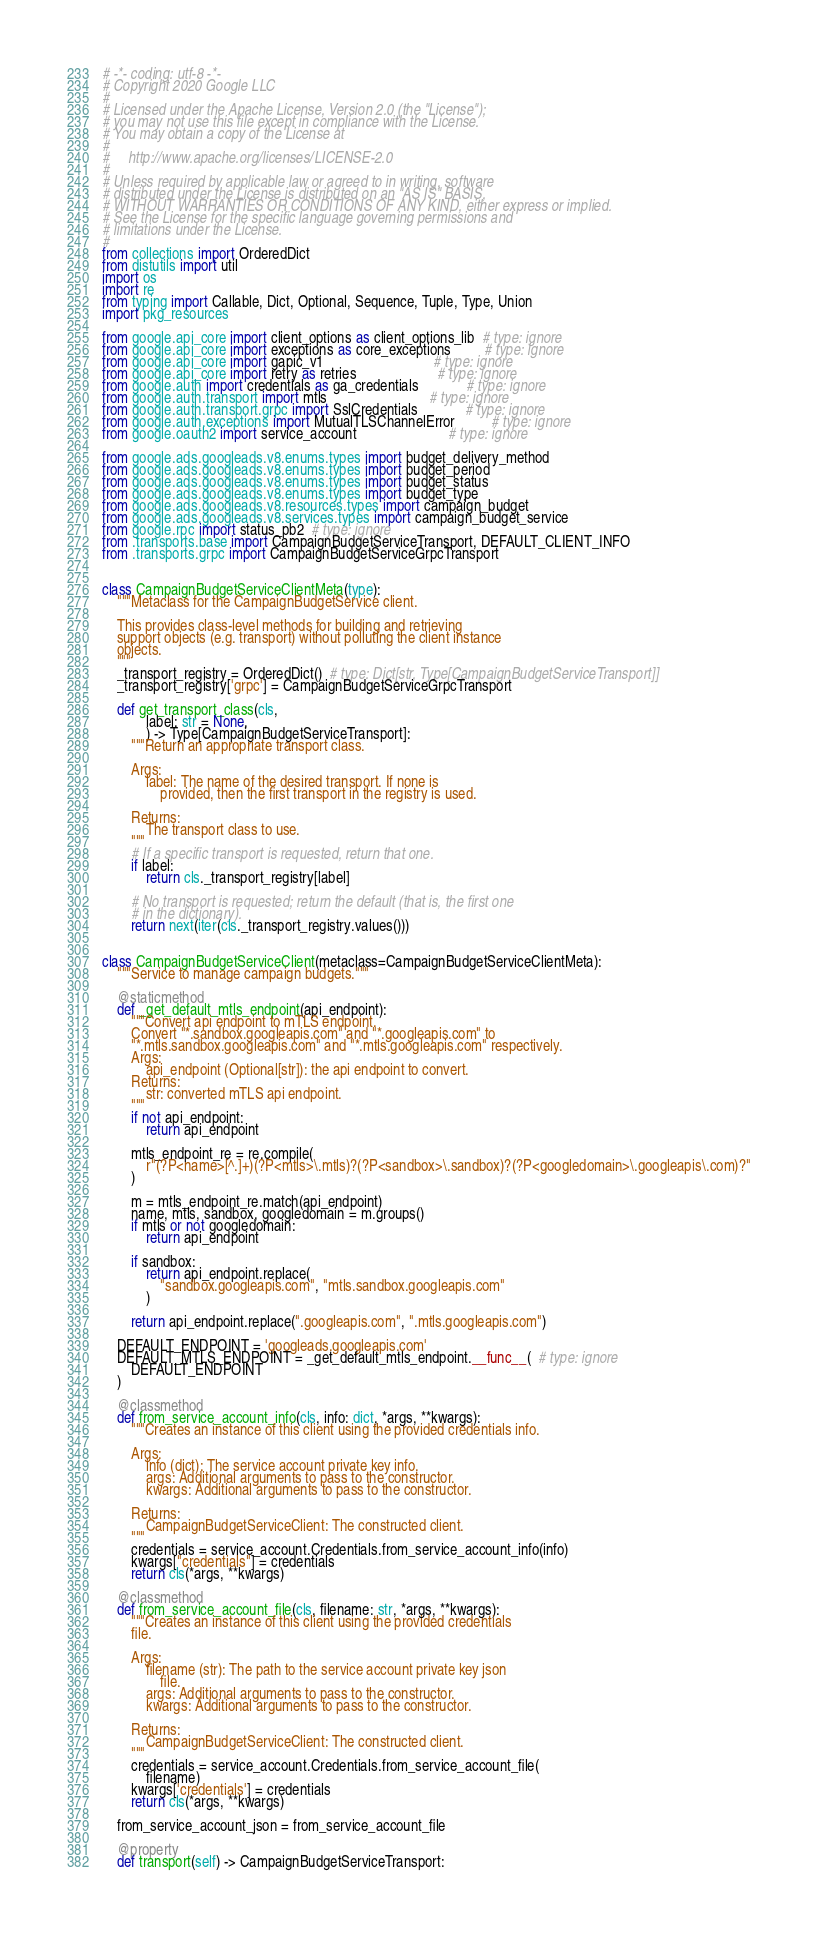Convert code to text. <code><loc_0><loc_0><loc_500><loc_500><_Python_># -*- coding: utf-8 -*-
# Copyright 2020 Google LLC
#
# Licensed under the Apache License, Version 2.0 (the "License");
# you may not use this file except in compliance with the License.
# You may obtain a copy of the License at
#
#     http://www.apache.org/licenses/LICENSE-2.0
#
# Unless required by applicable law or agreed to in writing, software
# distributed under the License is distributed on an "AS IS" BASIS,
# WITHOUT WARRANTIES OR CONDITIONS OF ANY KIND, either express or implied.
# See the License for the specific language governing permissions and
# limitations under the License.
#
from collections import OrderedDict
from distutils import util
import os
import re
from typing import Callable, Dict, Optional, Sequence, Tuple, Type, Union
import pkg_resources

from google.api_core import client_options as client_options_lib  # type: ignore
from google.api_core import exceptions as core_exceptions         # type: ignore
from google.api_core import gapic_v1                              # type: ignore
from google.api_core import retry as retries                      # type: ignore
from google.auth import credentials as ga_credentials             # type: ignore
from google.auth.transport import mtls                            # type: ignore
from google.auth.transport.grpc import SslCredentials             # type: ignore
from google.auth.exceptions import MutualTLSChannelError          # type: ignore
from google.oauth2 import service_account                         # type: ignore

from google.ads.googleads.v8.enums.types import budget_delivery_method
from google.ads.googleads.v8.enums.types import budget_period
from google.ads.googleads.v8.enums.types import budget_status
from google.ads.googleads.v8.enums.types import budget_type
from google.ads.googleads.v8.resources.types import campaign_budget
from google.ads.googleads.v8.services.types import campaign_budget_service
from google.rpc import status_pb2  # type: ignore
from .transports.base import CampaignBudgetServiceTransport, DEFAULT_CLIENT_INFO
from .transports.grpc import CampaignBudgetServiceGrpcTransport


class CampaignBudgetServiceClientMeta(type):
    """Metaclass for the CampaignBudgetService client.

    This provides class-level methods for building and retrieving
    support objects (e.g. transport) without polluting the client instance
    objects.
    """
    _transport_registry = OrderedDict()  # type: Dict[str, Type[CampaignBudgetServiceTransport]]
    _transport_registry['grpc'] = CampaignBudgetServiceGrpcTransport

    def get_transport_class(cls,
            label: str = None,
            ) -> Type[CampaignBudgetServiceTransport]:
        """Return an appropriate transport class.

        Args:
            label: The name of the desired transport. If none is
                provided, then the first transport in the registry is used.

        Returns:
            The transport class to use.
        """
        # If a specific transport is requested, return that one.
        if label:
            return cls._transport_registry[label]

        # No transport is requested; return the default (that is, the first one
        # in the dictionary).
        return next(iter(cls._transport_registry.values()))


class CampaignBudgetServiceClient(metaclass=CampaignBudgetServiceClientMeta):
    """Service to manage campaign budgets."""

    @staticmethod
    def _get_default_mtls_endpoint(api_endpoint):
        """Convert api endpoint to mTLS endpoint.
        Convert "*.sandbox.googleapis.com" and "*.googleapis.com" to
        "*.mtls.sandbox.googleapis.com" and "*.mtls.googleapis.com" respectively.
        Args:
            api_endpoint (Optional[str]): the api endpoint to convert.
        Returns:
            str: converted mTLS api endpoint.
        """
        if not api_endpoint:
            return api_endpoint

        mtls_endpoint_re = re.compile(
            r"(?P<name>[^.]+)(?P<mtls>\.mtls)?(?P<sandbox>\.sandbox)?(?P<googledomain>\.googleapis\.com)?"
        )

        m = mtls_endpoint_re.match(api_endpoint)
        name, mtls, sandbox, googledomain = m.groups()
        if mtls or not googledomain:
            return api_endpoint

        if sandbox:
            return api_endpoint.replace(
                "sandbox.googleapis.com", "mtls.sandbox.googleapis.com"
            )

        return api_endpoint.replace(".googleapis.com", ".mtls.googleapis.com")

    DEFAULT_ENDPOINT = 'googleads.googleapis.com'
    DEFAULT_MTLS_ENDPOINT = _get_default_mtls_endpoint.__func__(  # type: ignore
        DEFAULT_ENDPOINT
    )

    @classmethod
    def from_service_account_info(cls, info: dict, *args, **kwargs):
        """Creates an instance of this client using the provided credentials info.

        Args:
            info (dict): The service account private key info.
            args: Additional arguments to pass to the constructor.
            kwargs: Additional arguments to pass to the constructor.

        Returns:
            CampaignBudgetServiceClient: The constructed client.
        """
        credentials = service_account.Credentials.from_service_account_info(info)
        kwargs["credentials"] = credentials
        return cls(*args, **kwargs)

    @classmethod
    def from_service_account_file(cls, filename: str, *args, **kwargs):
        """Creates an instance of this client using the provided credentials
        file.

        Args:
            filename (str): The path to the service account private key json
                file.
            args: Additional arguments to pass to the constructor.
            kwargs: Additional arguments to pass to the constructor.

        Returns:
            CampaignBudgetServiceClient: The constructed client.
        """
        credentials = service_account.Credentials.from_service_account_file(
            filename)
        kwargs['credentials'] = credentials
        return cls(*args, **kwargs)

    from_service_account_json = from_service_account_file

    @property
    def transport(self) -> CampaignBudgetServiceTransport:</code> 